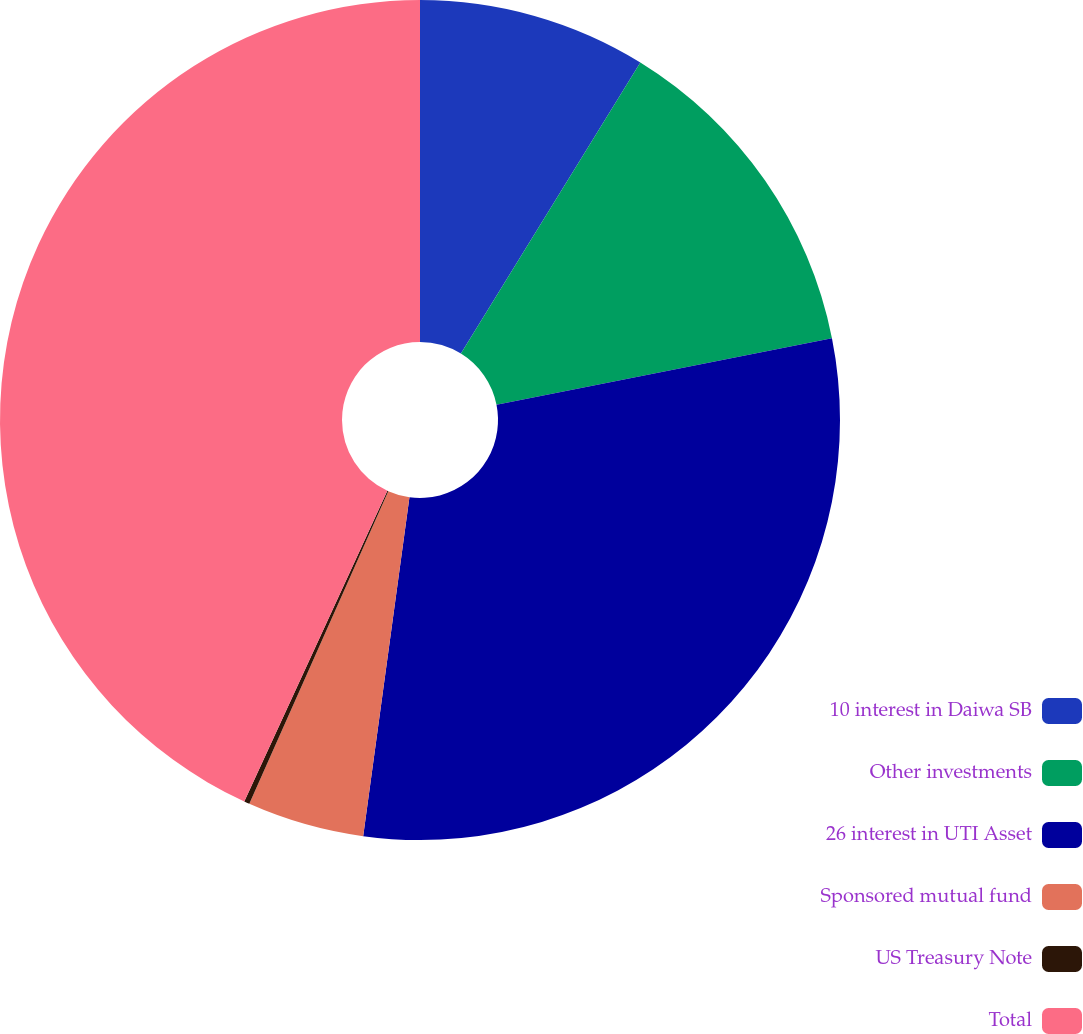<chart> <loc_0><loc_0><loc_500><loc_500><pie_chart><fcel>10 interest in Daiwa SB<fcel>Other investments<fcel>26 interest in UTI Asset<fcel>Sponsored mutual fund<fcel>US Treasury Note<fcel>Total<nl><fcel>8.79%<fcel>13.09%<fcel>30.28%<fcel>4.5%<fcel>0.21%<fcel>43.13%<nl></chart> 